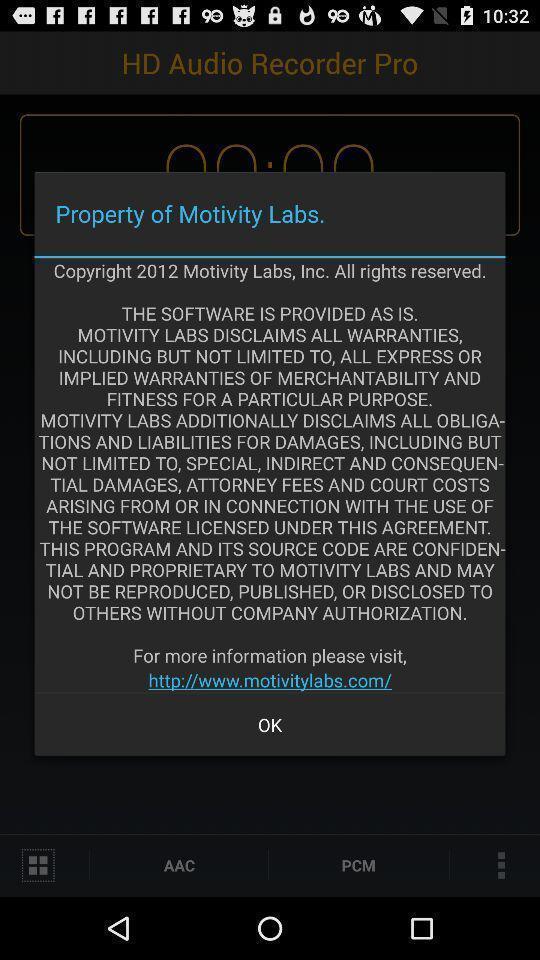Summarize the main components in this picture. Pop-up showing details. 